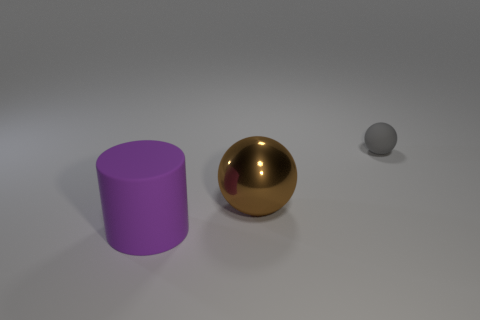What number of other brown objects have the same shape as the tiny object? There are no brown objects in the image; however, if we consider objects with a similar shape as the tiny sphere, there is one large golden sphere present. 